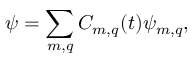Convert formula to latex. <formula><loc_0><loc_0><loc_500><loc_500>\psi = \sum _ { m , q } C _ { m , q } ( t ) \psi _ { m , q } ,</formula> 